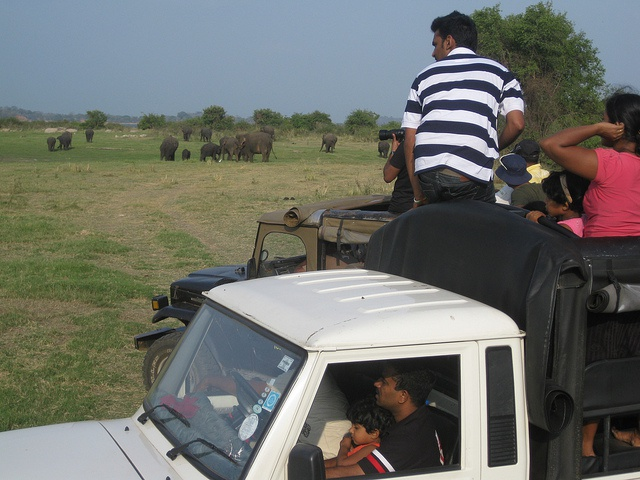Describe the objects in this image and their specific colors. I can see truck in darkgray, black, lightgray, and gray tones, people in darkgray, lavender, black, and gray tones, car in darkgray, gray, and black tones, people in darkgray, black, brown, and maroon tones, and people in darkgray, black, maroon, brown, and lightgray tones in this image. 